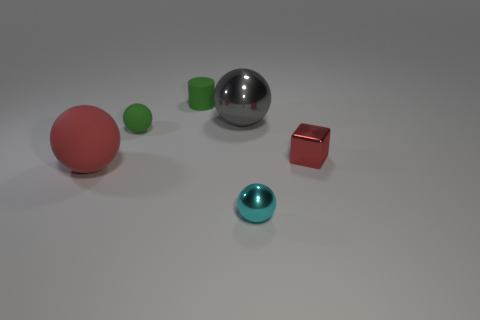Subtract all tiny cyan balls. How many balls are left? 3 Add 3 tiny red things. How many objects exist? 9 Subtract all red spheres. How many spheres are left? 3 Subtract 3 balls. How many balls are left? 1 Subtract all spheres. How many objects are left? 2 Subtract all yellow balls. Subtract all green blocks. How many balls are left? 4 Subtract all small red cubes. Subtract all big gray spheres. How many objects are left? 4 Add 5 tiny cylinders. How many tiny cylinders are left? 6 Add 1 large red things. How many large red things exist? 2 Subtract 0 blue cylinders. How many objects are left? 6 